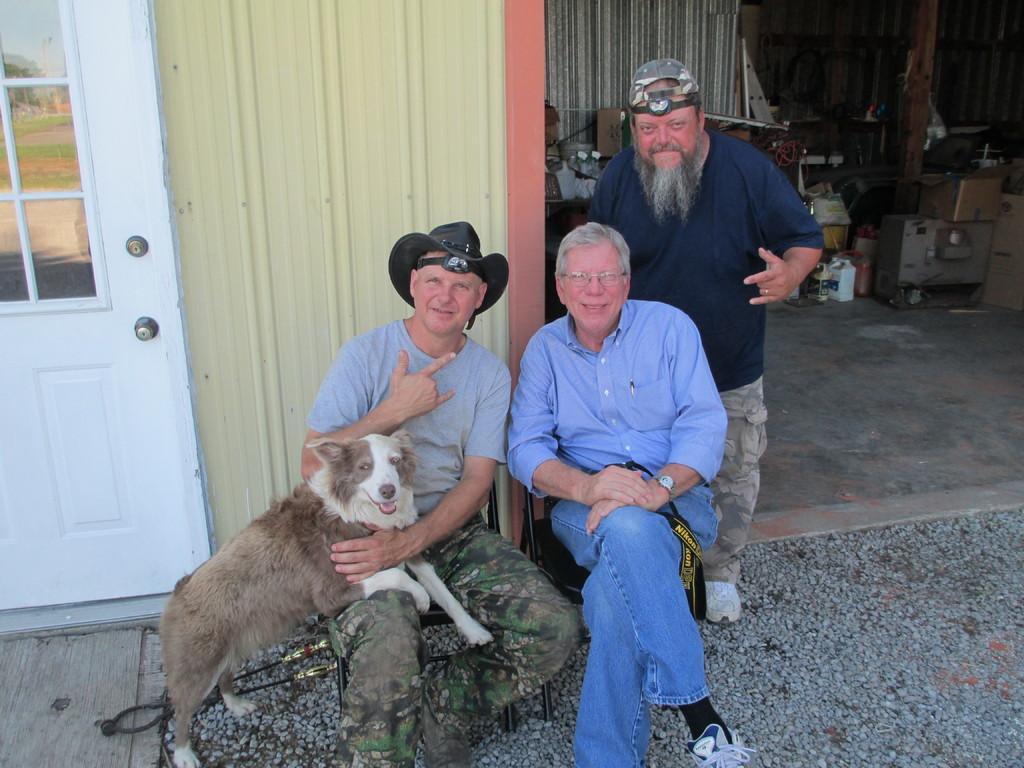What is one of the main objects in the image? There is a door in the image. What type of animal is present in the image? There is a dog in the image. How many people are in the image? There are three people in the image. How does the dog increase its size in the image? The dog does not increase its size in the image; it remains the same size throughout the image. What type of worm can be seen crawling on the floor in the image? There is no worm present in the image. 